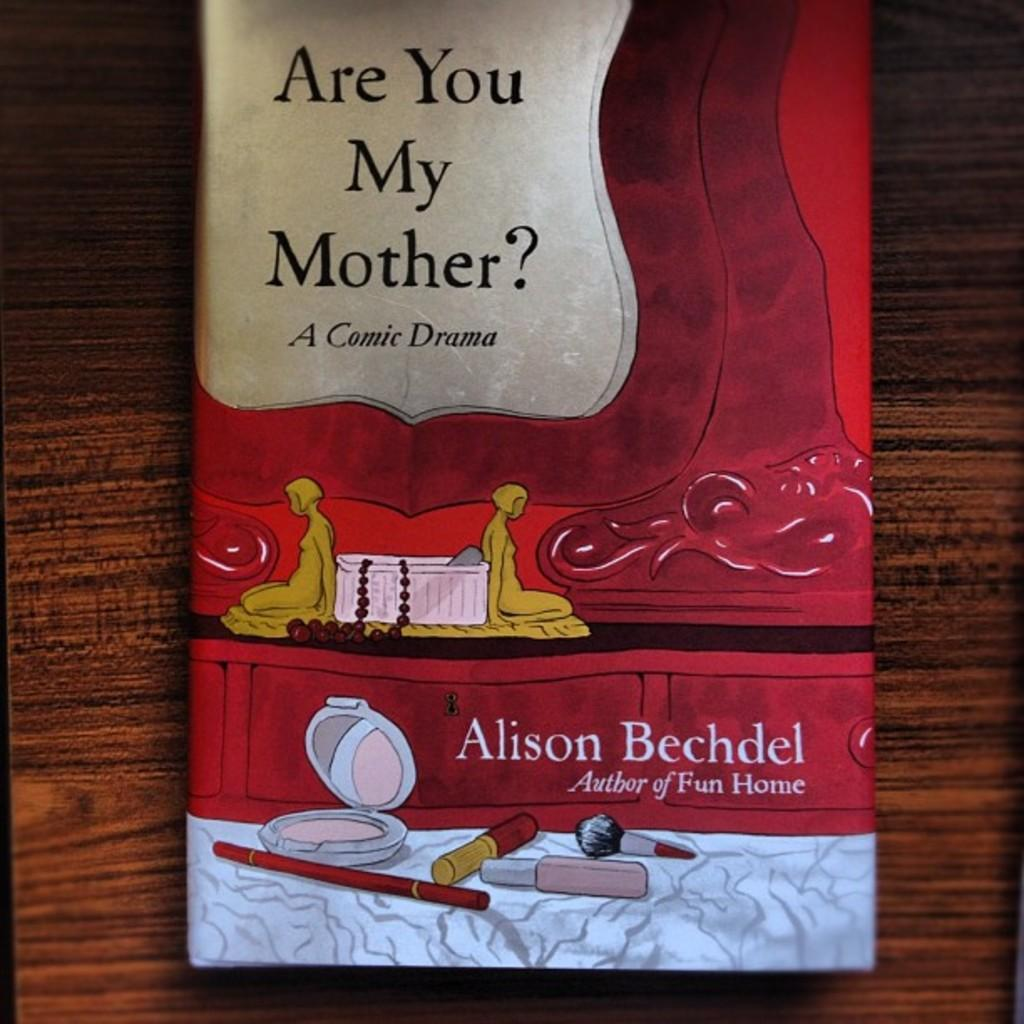<image>
Present a compact description of the photo's key features. The book is called are you my mother and it is a comic drama. 